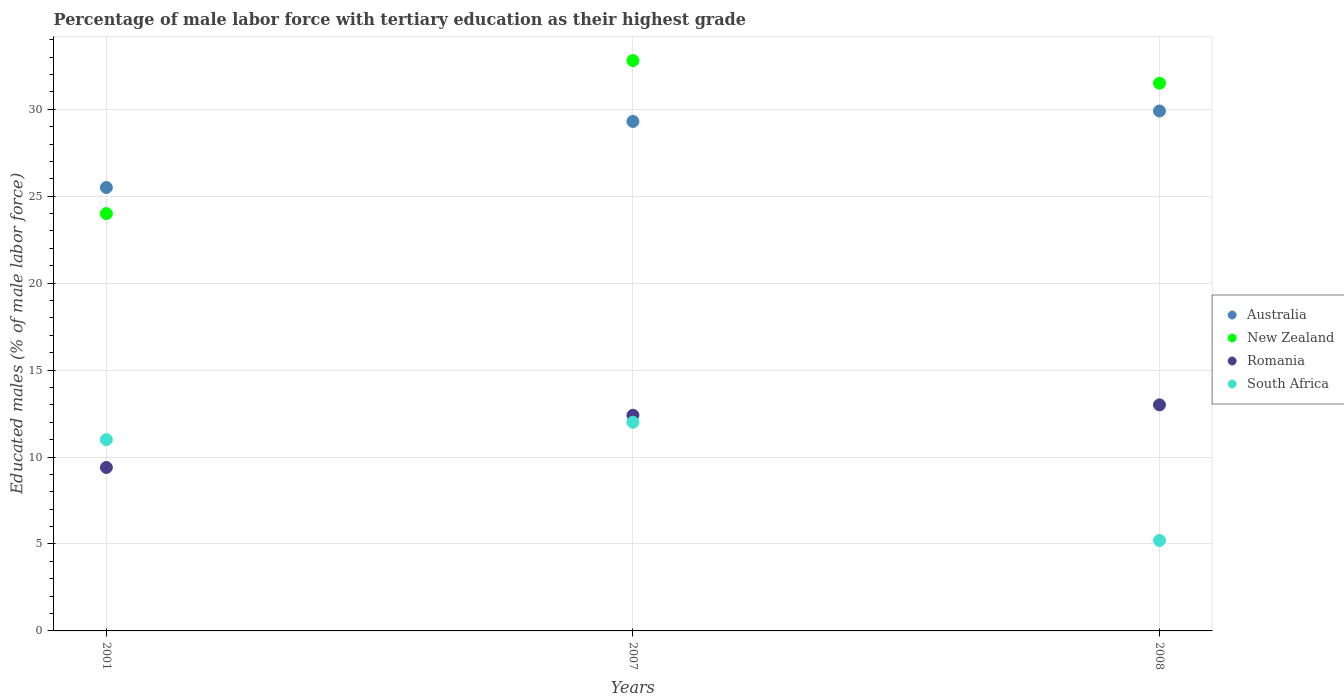What is the percentage of male labor force with tertiary education in Romania in 2008?
Ensure brevity in your answer.  13. Across all years, what is the maximum percentage of male labor force with tertiary education in New Zealand?
Provide a succinct answer. 32.8. Across all years, what is the minimum percentage of male labor force with tertiary education in New Zealand?
Keep it short and to the point. 24. In which year was the percentage of male labor force with tertiary education in South Africa maximum?
Give a very brief answer. 2007. What is the total percentage of male labor force with tertiary education in Romania in the graph?
Provide a short and direct response. 34.8. What is the difference between the percentage of male labor force with tertiary education in New Zealand in 2007 and the percentage of male labor force with tertiary education in Romania in 2008?
Keep it short and to the point. 19.8. What is the average percentage of male labor force with tertiary education in Australia per year?
Your answer should be compact. 28.23. In the year 2001, what is the difference between the percentage of male labor force with tertiary education in Australia and percentage of male labor force with tertiary education in South Africa?
Provide a succinct answer. 14.5. What is the ratio of the percentage of male labor force with tertiary education in South Africa in 2007 to that in 2008?
Keep it short and to the point. 2.31. Is the percentage of male labor force with tertiary education in South Africa in 2007 less than that in 2008?
Your response must be concise. No. Is the difference between the percentage of male labor force with tertiary education in Australia in 2001 and 2007 greater than the difference between the percentage of male labor force with tertiary education in South Africa in 2001 and 2007?
Provide a short and direct response. No. What is the difference between the highest and the lowest percentage of male labor force with tertiary education in Romania?
Provide a succinct answer. 3.6. In how many years, is the percentage of male labor force with tertiary education in New Zealand greater than the average percentage of male labor force with tertiary education in New Zealand taken over all years?
Your answer should be very brief. 2. Is the sum of the percentage of male labor force with tertiary education in New Zealand in 2001 and 2007 greater than the maximum percentage of male labor force with tertiary education in Australia across all years?
Your response must be concise. Yes. Is it the case that in every year, the sum of the percentage of male labor force with tertiary education in South Africa and percentage of male labor force with tertiary education in Australia  is greater than the sum of percentage of male labor force with tertiary education in New Zealand and percentage of male labor force with tertiary education in Romania?
Make the answer very short. Yes. Does the percentage of male labor force with tertiary education in Romania monotonically increase over the years?
Make the answer very short. Yes. Are the values on the major ticks of Y-axis written in scientific E-notation?
Keep it short and to the point. No. Does the graph contain any zero values?
Provide a succinct answer. No. Where does the legend appear in the graph?
Make the answer very short. Center right. How many legend labels are there?
Offer a terse response. 4. How are the legend labels stacked?
Provide a succinct answer. Vertical. What is the title of the graph?
Your response must be concise. Percentage of male labor force with tertiary education as their highest grade. Does "Micronesia" appear as one of the legend labels in the graph?
Your answer should be compact. No. What is the label or title of the Y-axis?
Your response must be concise. Educated males (% of male labor force). What is the Educated males (% of male labor force) in New Zealand in 2001?
Offer a very short reply. 24. What is the Educated males (% of male labor force) in Romania in 2001?
Your answer should be compact. 9.4. What is the Educated males (% of male labor force) in Australia in 2007?
Provide a short and direct response. 29.3. What is the Educated males (% of male labor force) in New Zealand in 2007?
Offer a terse response. 32.8. What is the Educated males (% of male labor force) in Romania in 2007?
Your answer should be compact. 12.4. What is the Educated males (% of male labor force) of Australia in 2008?
Your response must be concise. 29.9. What is the Educated males (% of male labor force) in New Zealand in 2008?
Give a very brief answer. 31.5. What is the Educated males (% of male labor force) of South Africa in 2008?
Keep it short and to the point. 5.2. Across all years, what is the maximum Educated males (% of male labor force) in Australia?
Give a very brief answer. 29.9. Across all years, what is the maximum Educated males (% of male labor force) of New Zealand?
Your answer should be very brief. 32.8. Across all years, what is the minimum Educated males (% of male labor force) in Australia?
Offer a terse response. 25.5. Across all years, what is the minimum Educated males (% of male labor force) of New Zealand?
Your response must be concise. 24. Across all years, what is the minimum Educated males (% of male labor force) in Romania?
Make the answer very short. 9.4. Across all years, what is the minimum Educated males (% of male labor force) in South Africa?
Make the answer very short. 5.2. What is the total Educated males (% of male labor force) in Australia in the graph?
Offer a terse response. 84.7. What is the total Educated males (% of male labor force) in New Zealand in the graph?
Your answer should be very brief. 88.3. What is the total Educated males (% of male labor force) in Romania in the graph?
Offer a very short reply. 34.8. What is the total Educated males (% of male labor force) of South Africa in the graph?
Make the answer very short. 28.2. What is the difference between the Educated males (% of male labor force) in South Africa in 2001 and that in 2007?
Offer a terse response. -1. What is the difference between the Educated males (% of male labor force) of Australia in 2001 and that in 2008?
Offer a terse response. -4.4. What is the difference between the Educated males (% of male labor force) of South Africa in 2007 and that in 2008?
Keep it short and to the point. 6.8. What is the difference between the Educated males (% of male labor force) in Australia in 2001 and the Educated males (% of male labor force) in New Zealand in 2007?
Your answer should be very brief. -7.3. What is the difference between the Educated males (% of male labor force) in Australia in 2001 and the Educated males (% of male labor force) in Romania in 2007?
Your answer should be very brief. 13.1. What is the difference between the Educated males (% of male labor force) in New Zealand in 2001 and the Educated males (% of male labor force) in South Africa in 2007?
Make the answer very short. 12. What is the difference between the Educated males (% of male labor force) of Australia in 2001 and the Educated males (% of male labor force) of South Africa in 2008?
Keep it short and to the point. 20.3. What is the difference between the Educated males (% of male labor force) of Romania in 2001 and the Educated males (% of male labor force) of South Africa in 2008?
Keep it short and to the point. 4.2. What is the difference between the Educated males (% of male labor force) in Australia in 2007 and the Educated males (% of male labor force) in Romania in 2008?
Ensure brevity in your answer.  16.3. What is the difference between the Educated males (% of male labor force) in Australia in 2007 and the Educated males (% of male labor force) in South Africa in 2008?
Provide a short and direct response. 24.1. What is the difference between the Educated males (% of male labor force) in New Zealand in 2007 and the Educated males (% of male labor force) in Romania in 2008?
Ensure brevity in your answer.  19.8. What is the difference between the Educated males (% of male labor force) in New Zealand in 2007 and the Educated males (% of male labor force) in South Africa in 2008?
Your answer should be very brief. 27.6. What is the difference between the Educated males (% of male labor force) of Romania in 2007 and the Educated males (% of male labor force) of South Africa in 2008?
Give a very brief answer. 7.2. What is the average Educated males (% of male labor force) of Australia per year?
Your answer should be compact. 28.23. What is the average Educated males (% of male labor force) in New Zealand per year?
Give a very brief answer. 29.43. What is the average Educated males (% of male labor force) of Romania per year?
Give a very brief answer. 11.6. In the year 2001, what is the difference between the Educated males (% of male labor force) in Australia and Educated males (% of male labor force) in New Zealand?
Provide a short and direct response. 1.5. In the year 2001, what is the difference between the Educated males (% of male labor force) in Australia and Educated males (% of male labor force) in Romania?
Ensure brevity in your answer.  16.1. In the year 2001, what is the difference between the Educated males (% of male labor force) in Australia and Educated males (% of male labor force) in South Africa?
Offer a very short reply. 14.5. In the year 2001, what is the difference between the Educated males (% of male labor force) of New Zealand and Educated males (% of male labor force) of South Africa?
Ensure brevity in your answer.  13. In the year 2007, what is the difference between the Educated males (% of male labor force) of New Zealand and Educated males (% of male labor force) of Romania?
Keep it short and to the point. 20.4. In the year 2007, what is the difference between the Educated males (% of male labor force) in New Zealand and Educated males (% of male labor force) in South Africa?
Give a very brief answer. 20.8. In the year 2008, what is the difference between the Educated males (% of male labor force) in Australia and Educated males (% of male labor force) in South Africa?
Your answer should be very brief. 24.7. In the year 2008, what is the difference between the Educated males (% of male labor force) in New Zealand and Educated males (% of male labor force) in Romania?
Give a very brief answer. 18.5. In the year 2008, what is the difference between the Educated males (% of male labor force) of New Zealand and Educated males (% of male labor force) of South Africa?
Your response must be concise. 26.3. In the year 2008, what is the difference between the Educated males (% of male labor force) in Romania and Educated males (% of male labor force) in South Africa?
Your answer should be very brief. 7.8. What is the ratio of the Educated males (% of male labor force) of Australia in 2001 to that in 2007?
Offer a terse response. 0.87. What is the ratio of the Educated males (% of male labor force) of New Zealand in 2001 to that in 2007?
Give a very brief answer. 0.73. What is the ratio of the Educated males (% of male labor force) of Romania in 2001 to that in 2007?
Your answer should be compact. 0.76. What is the ratio of the Educated males (% of male labor force) of Australia in 2001 to that in 2008?
Your answer should be very brief. 0.85. What is the ratio of the Educated males (% of male labor force) of New Zealand in 2001 to that in 2008?
Your answer should be compact. 0.76. What is the ratio of the Educated males (% of male labor force) of Romania in 2001 to that in 2008?
Your response must be concise. 0.72. What is the ratio of the Educated males (% of male labor force) in South Africa in 2001 to that in 2008?
Offer a very short reply. 2.12. What is the ratio of the Educated males (% of male labor force) in Australia in 2007 to that in 2008?
Offer a terse response. 0.98. What is the ratio of the Educated males (% of male labor force) of New Zealand in 2007 to that in 2008?
Offer a very short reply. 1.04. What is the ratio of the Educated males (% of male labor force) of Romania in 2007 to that in 2008?
Give a very brief answer. 0.95. What is the ratio of the Educated males (% of male labor force) of South Africa in 2007 to that in 2008?
Your response must be concise. 2.31. What is the difference between the highest and the second highest Educated males (% of male labor force) in Australia?
Make the answer very short. 0.6. What is the difference between the highest and the second highest Educated males (% of male labor force) in New Zealand?
Provide a short and direct response. 1.3. What is the difference between the highest and the second highest Educated males (% of male labor force) of South Africa?
Your answer should be compact. 1. What is the difference between the highest and the lowest Educated males (% of male labor force) of Australia?
Offer a very short reply. 4.4. What is the difference between the highest and the lowest Educated males (% of male labor force) in Romania?
Provide a succinct answer. 3.6. What is the difference between the highest and the lowest Educated males (% of male labor force) of South Africa?
Offer a terse response. 6.8. 